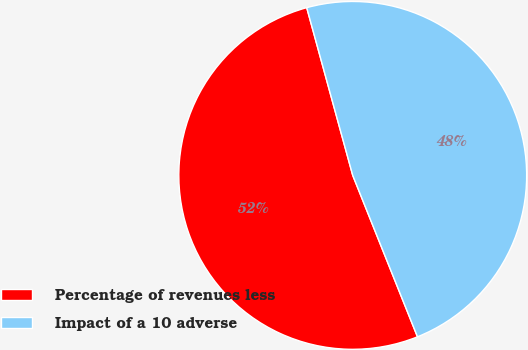Convert chart to OTSL. <chart><loc_0><loc_0><loc_500><loc_500><pie_chart><fcel>Percentage of revenues less<fcel>Impact of a 10 adverse<nl><fcel>51.81%<fcel>48.19%<nl></chart> 